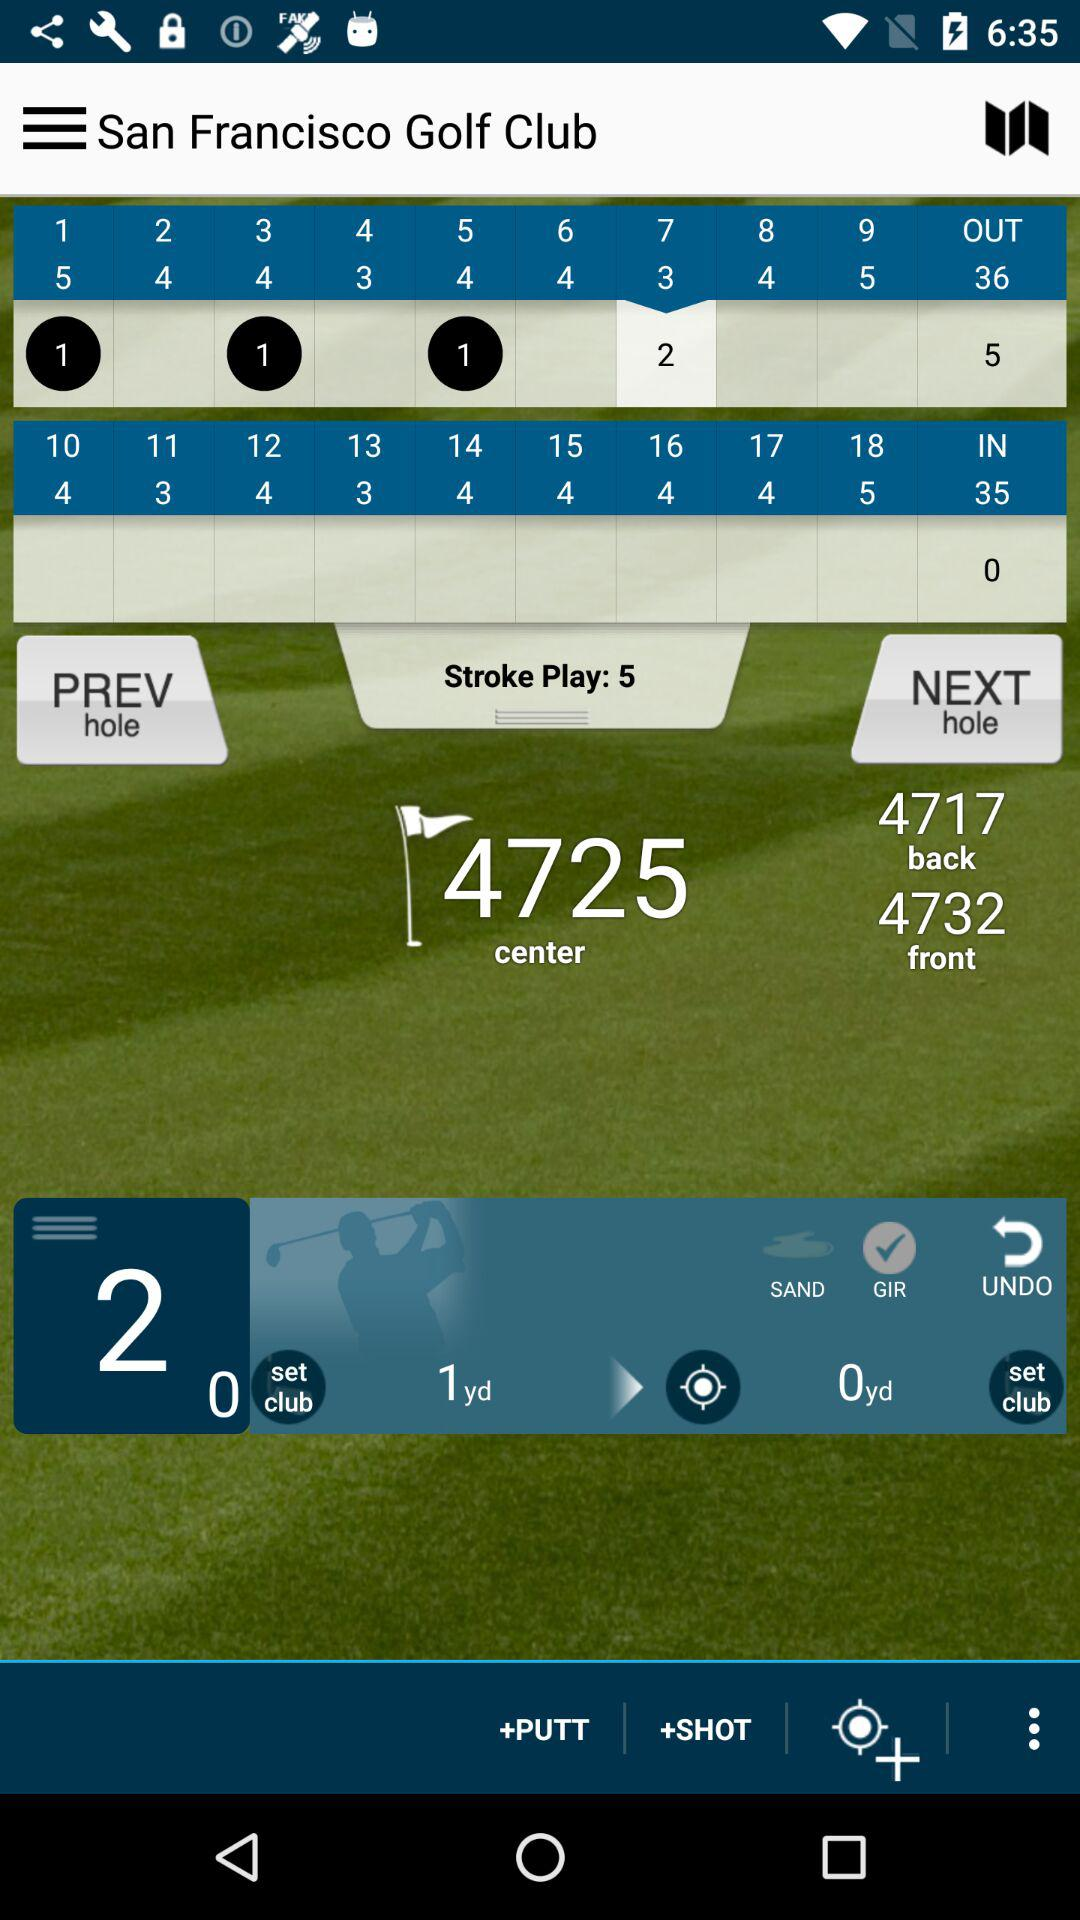What is the location of golf club? The location is San Francisco. 